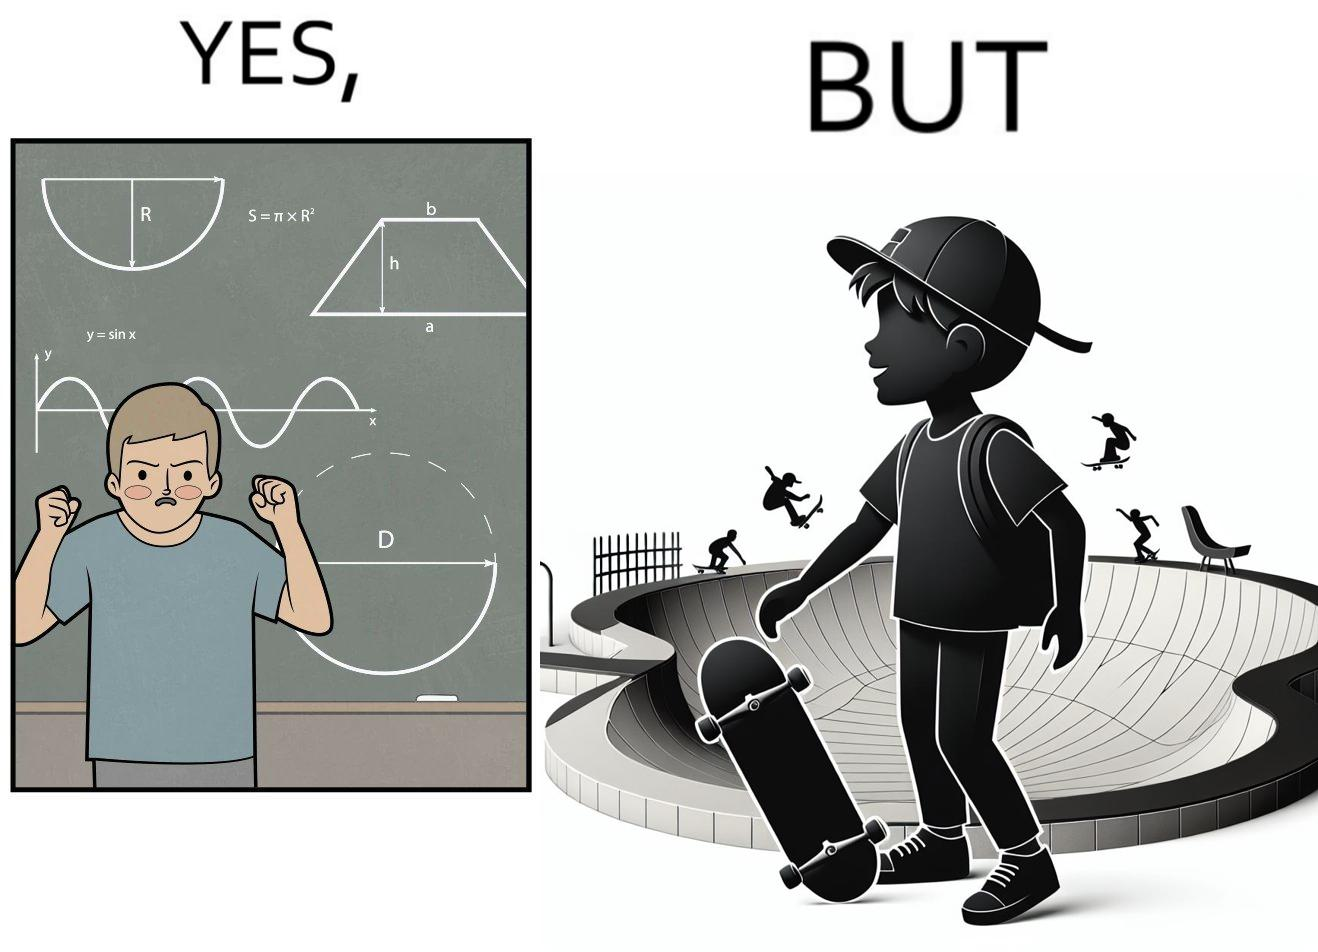Explain why this image is satirical. The image is ironical beaucse while the boy does not enjoy studying mathematics and different geometric shapes like semi circle and trapezoid and graphs of trigonometric equations like that of a sine wave, he enjoys skateboarding on surfaces and bowls that are built based on the said geometric shapes and graphs of trigonometric equations. 